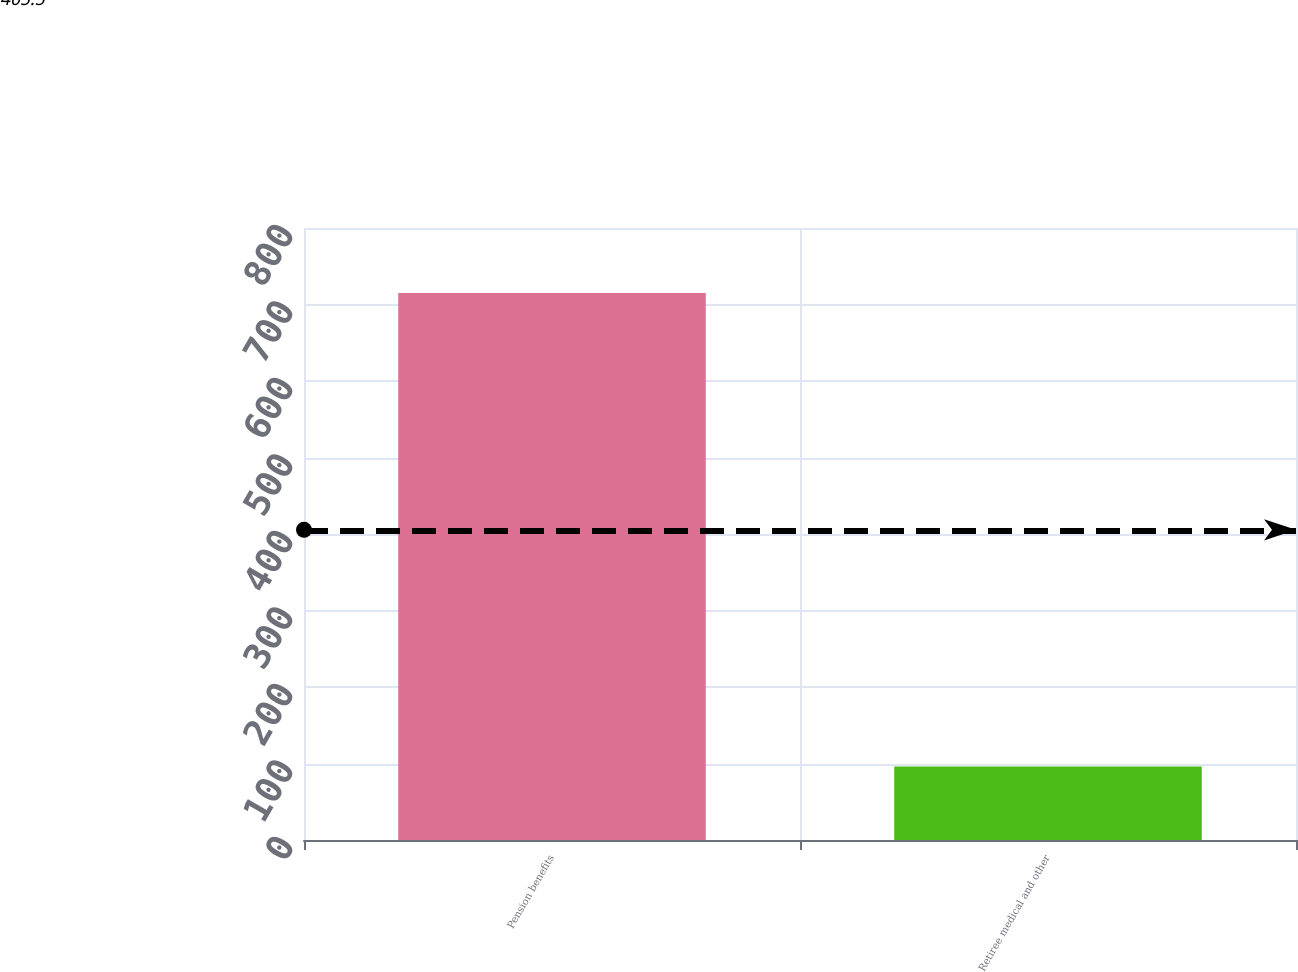<chart> <loc_0><loc_0><loc_500><loc_500><bar_chart><fcel>Pension benefits<fcel>Retiree medical and other<nl><fcel>715<fcel>96<nl></chart> 